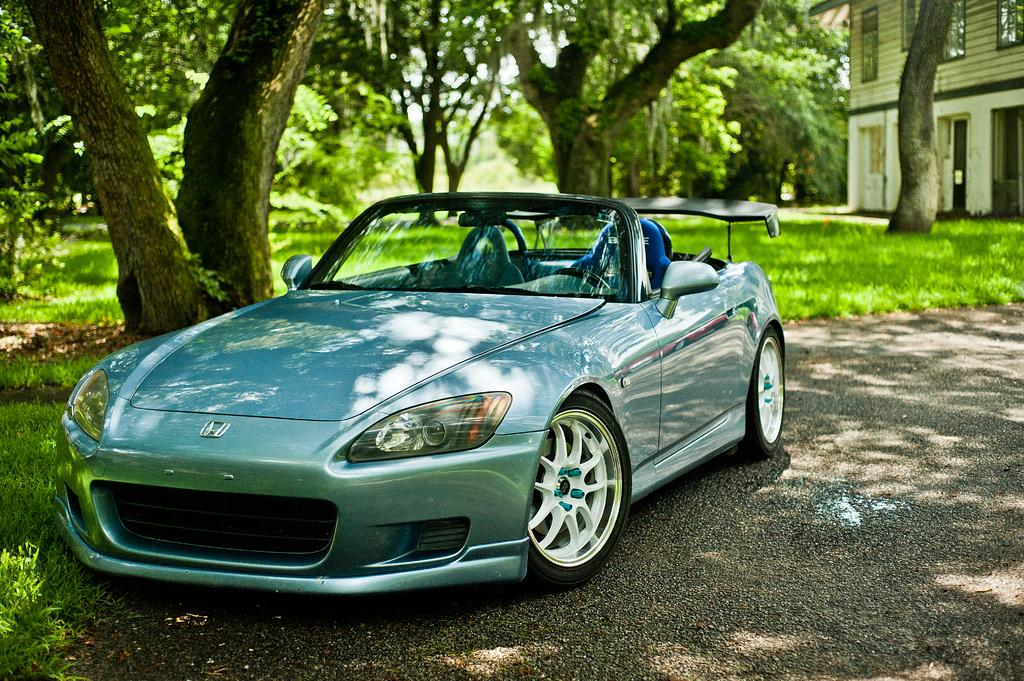What is the main subject of the image? The main subject of the image is a car. Where is the car located in the image? The car is on the road in the middle of the image. What can be seen in the background of the image? In the background of the image, there is grass, trees, the sky, and a building. What is the weather like in the image? The image was taken during a sunny day. Can you see any icicles hanging from the car in the image? No, there are no icicles present in the image. What type of face can be seen on the building in the background? There is no face visible on the building in the background; it is a regular building. 